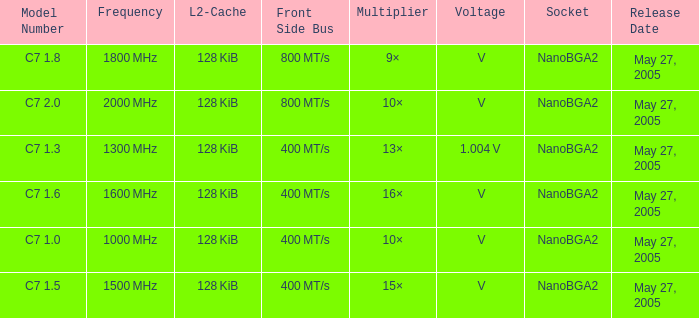What is the Release Date for Model Number c7 1.8? May 27, 2005. 